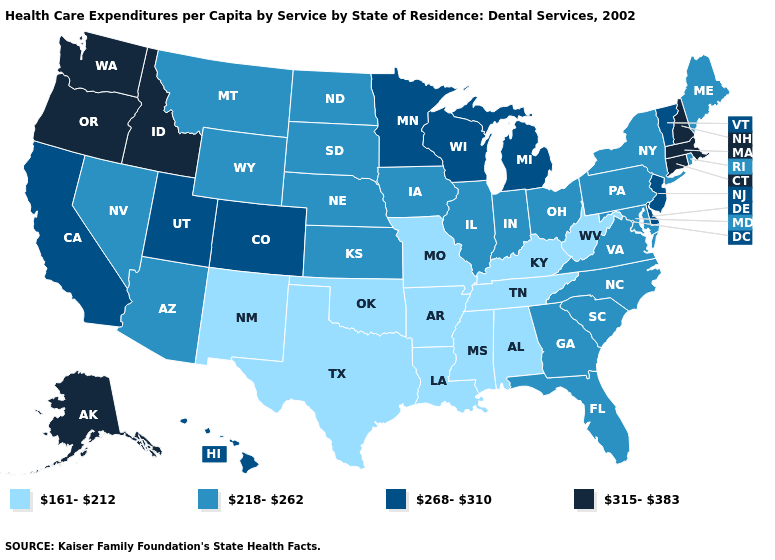Is the legend a continuous bar?
Give a very brief answer. No. Does Oklahoma have the lowest value in the USA?
Answer briefly. Yes. Does Connecticut have the highest value in the USA?
Write a very short answer. Yes. Does New Hampshire have the highest value in the USA?
Short answer required. Yes. Which states hav the highest value in the South?
Concise answer only. Delaware. What is the highest value in the USA?
Quick response, please. 315-383. Name the states that have a value in the range 315-383?
Concise answer only. Alaska, Connecticut, Idaho, Massachusetts, New Hampshire, Oregon, Washington. What is the value of Arizona?
Write a very short answer. 218-262. What is the value of Iowa?
Keep it brief. 218-262. Name the states that have a value in the range 315-383?
Keep it brief. Alaska, Connecticut, Idaho, Massachusetts, New Hampshire, Oregon, Washington. Does Oregon have the same value as Florida?
Give a very brief answer. No. Name the states that have a value in the range 315-383?
Concise answer only. Alaska, Connecticut, Idaho, Massachusetts, New Hampshire, Oregon, Washington. Among the states that border Maryland , which have the lowest value?
Keep it brief. West Virginia. Among the states that border Idaho , which have the highest value?
Be succinct. Oregon, Washington. 